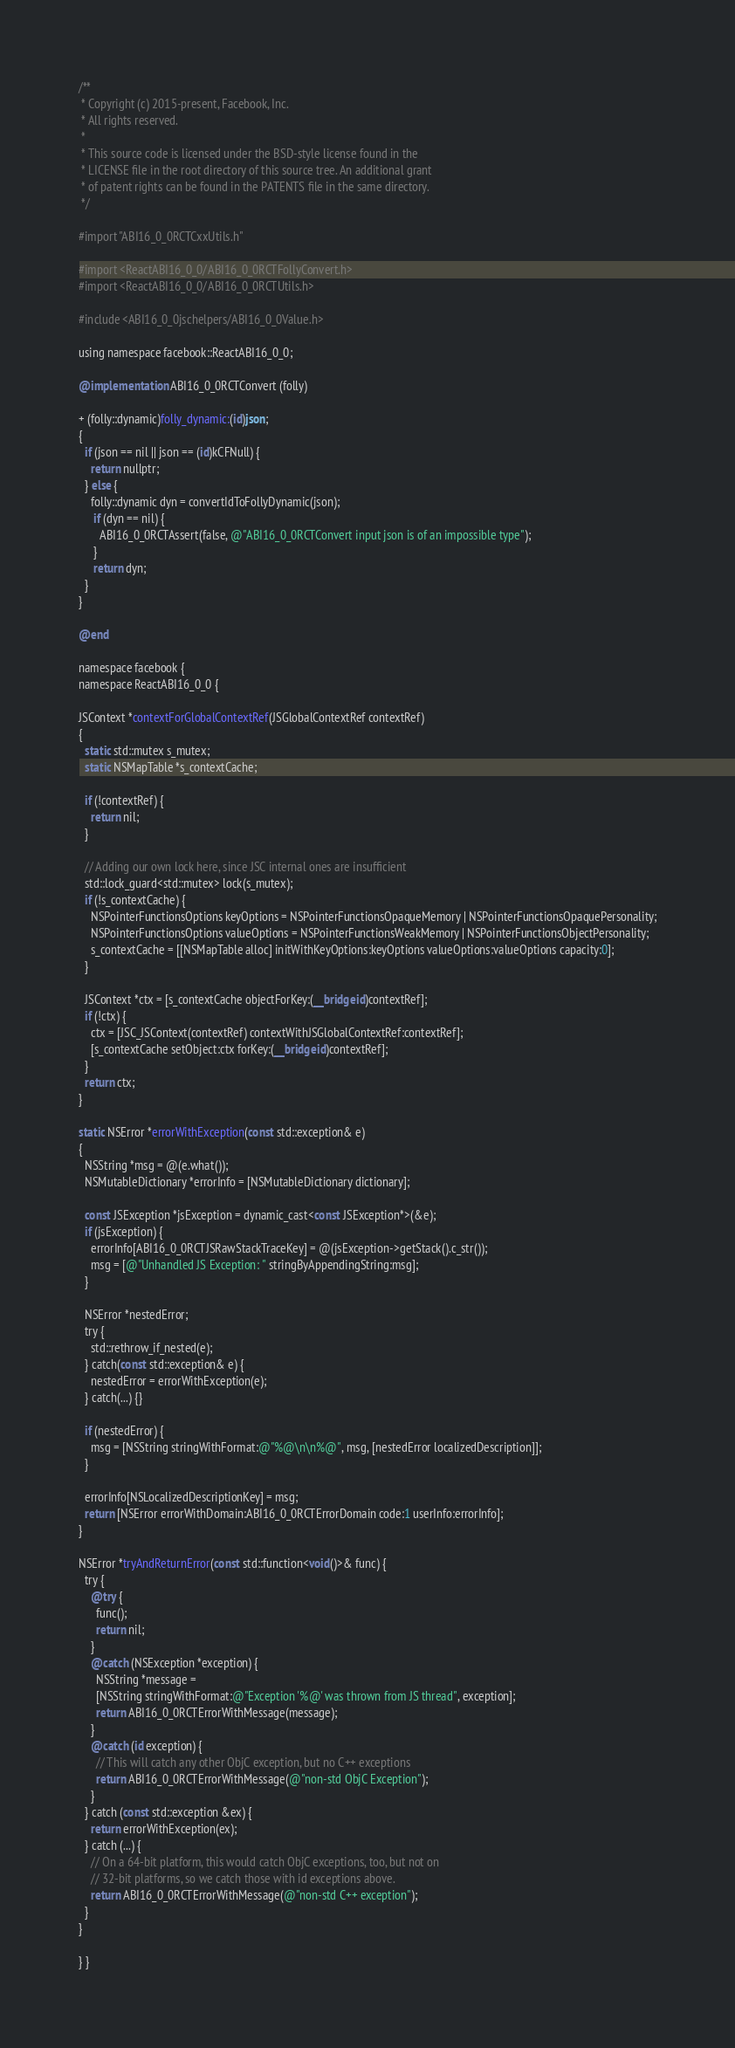Convert code to text. <code><loc_0><loc_0><loc_500><loc_500><_ObjectiveC_>/**
 * Copyright (c) 2015-present, Facebook, Inc.
 * All rights reserved.
 *
 * This source code is licensed under the BSD-style license found in the
 * LICENSE file in the root directory of this source tree. An additional grant
 * of patent rights can be found in the PATENTS file in the same directory.
 */

#import "ABI16_0_0RCTCxxUtils.h"

#import <ReactABI16_0_0/ABI16_0_0RCTFollyConvert.h>
#import <ReactABI16_0_0/ABI16_0_0RCTUtils.h>

#include <ABI16_0_0jschelpers/ABI16_0_0Value.h>

using namespace facebook::ReactABI16_0_0;

@implementation ABI16_0_0RCTConvert (folly)

+ (folly::dynamic)folly_dynamic:(id)json;
{
  if (json == nil || json == (id)kCFNull) {
    return nullptr;
  } else {
    folly::dynamic dyn = convertIdToFollyDynamic(json);
     if (dyn == nil) {
       ABI16_0_0RCTAssert(false, @"ABI16_0_0RCTConvert input json is of an impossible type");
     }
     return dyn;
  }
}

@end

namespace facebook {
namespace ReactABI16_0_0 {

JSContext *contextForGlobalContextRef(JSGlobalContextRef contextRef)
{
  static std::mutex s_mutex;
  static NSMapTable *s_contextCache;

  if (!contextRef) {
    return nil;
  }

  // Adding our own lock here, since JSC internal ones are insufficient
  std::lock_guard<std::mutex> lock(s_mutex);
  if (!s_contextCache) {
    NSPointerFunctionsOptions keyOptions = NSPointerFunctionsOpaqueMemory | NSPointerFunctionsOpaquePersonality;
    NSPointerFunctionsOptions valueOptions = NSPointerFunctionsWeakMemory | NSPointerFunctionsObjectPersonality;
    s_contextCache = [[NSMapTable alloc] initWithKeyOptions:keyOptions valueOptions:valueOptions capacity:0];
  }

  JSContext *ctx = [s_contextCache objectForKey:(__bridge id)contextRef];
  if (!ctx) {
    ctx = [JSC_JSContext(contextRef) contextWithJSGlobalContextRef:contextRef];
    [s_contextCache setObject:ctx forKey:(__bridge id)contextRef];
  }
  return ctx;
}

static NSError *errorWithException(const std::exception& e)
{
  NSString *msg = @(e.what());
  NSMutableDictionary *errorInfo = [NSMutableDictionary dictionary];

  const JSException *jsException = dynamic_cast<const JSException*>(&e);
  if (jsException) {
    errorInfo[ABI16_0_0RCTJSRawStackTraceKey] = @(jsException->getStack().c_str());
    msg = [@"Unhandled JS Exception: " stringByAppendingString:msg];
  }

  NSError *nestedError;
  try {
    std::rethrow_if_nested(e);
  } catch(const std::exception& e) {
    nestedError = errorWithException(e);
  } catch(...) {}

  if (nestedError) {
    msg = [NSString stringWithFormat:@"%@\n\n%@", msg, [nestedError localizedDescription]];
  }

  errorInfo[NSLocalizedDescriptionKey] = msg;
  return [NSError errorWithDomain:ABI16_0_0RCTErrorDomain code:1 userInfo:errorInfo];
}

NSError *tryAndReturnError(const std::function<void()>& func) {
  try {
    @try {
      func();
      return nil;
    }
    @catch (NSException *exception) {
      NSString *message =
      [NSString stringWithFormat:@"Exception '%@' was thrown from JS thread", exception];
      return ABI16_0_0RCTErrorWithMessage(message);
    }
    @catch (id exception) {
      // This will catch any other ObjC exception, but no C++ exceptions
      return ABI16_0_0RCTErrorWithMessage(@"non-std ObjC Exception");
    }
  } catch (const std::exception &ex) {
    return errorWithException(ex);
  } catch (...) {
    // On a 64-bit platform, this would catch ObjC exceptions, too, but not on
    // 32-bit platforms, so we catch those with id exceptions above.
    return ABI16_0_0RCTErrorWithMessage(@"non-std C++ exception");
  }
}

} }
</code> 